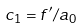<formula> <loc_0><loc_0><loc_500><loc_500>c _ { 1 } = f ^ { \prime } / a _ { 0 }</formula> 